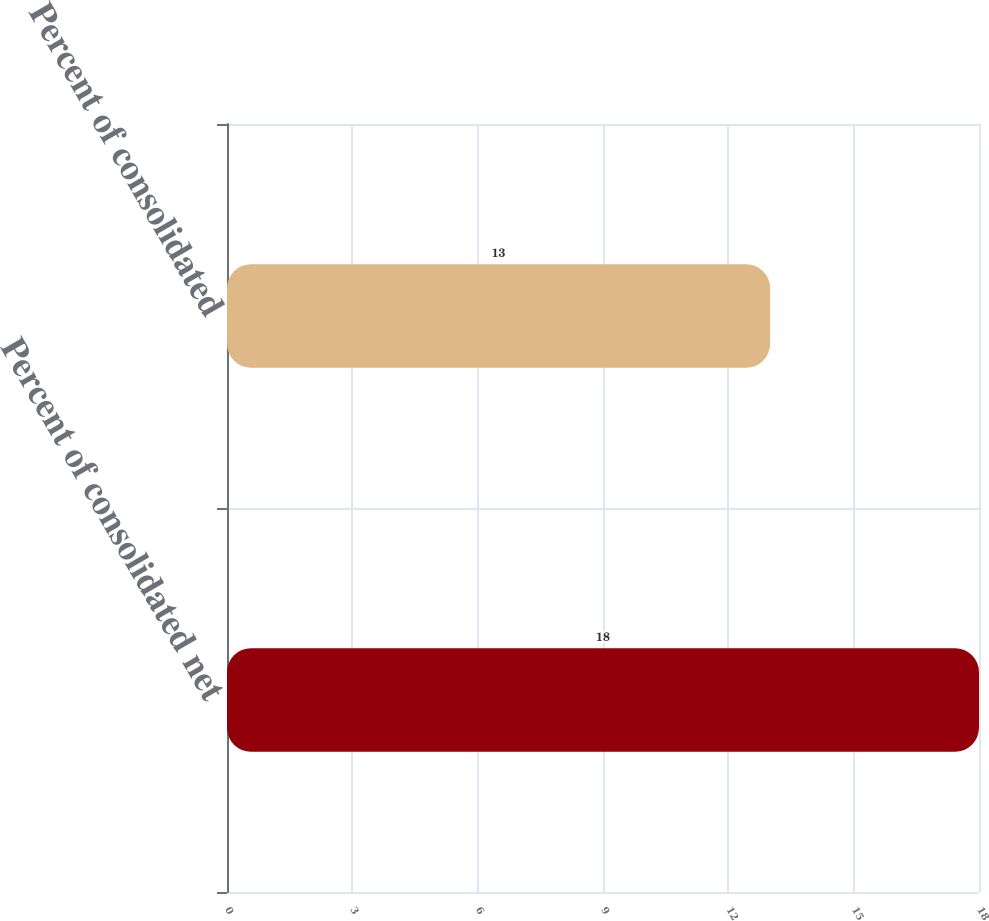Convert chart to OTSL. <chart><loc_0><loc_0><loc_500><loc_500><bar_chart><fcel>Percent of consolidated net<fcel>Percent of consolidated<nl><fcel>18<fcel>13<nl></chart> 